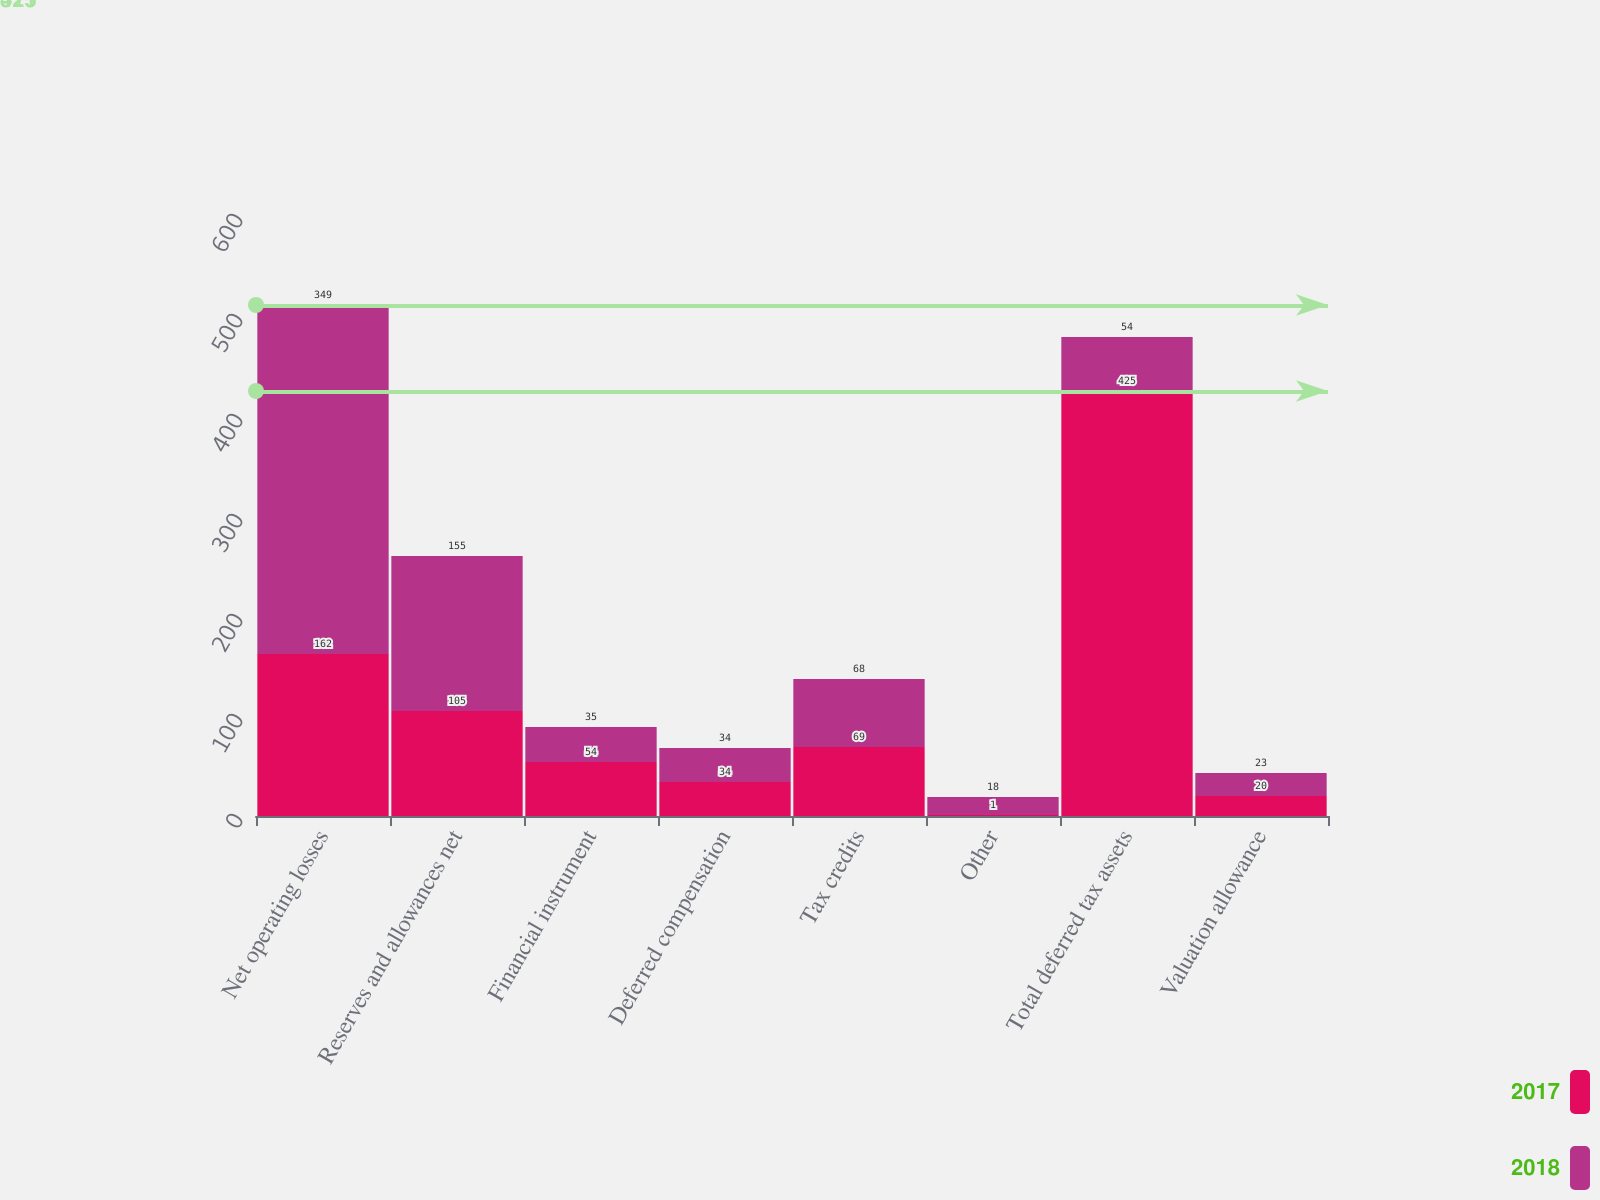Convert chart to OTSL. <chart><loc_0><loc_0><loc_500><loc_500><stacked_bar_chart><ecel><fcel>Net operating losses<fcel>Reserves and allowances net<fcel>Financial instrument<fcel>Deferred compensation<fcel>Tax credits<fcel>Other<fcel>Total deferred tax assets<fcel>Valuation allowance<nl><fcel>2017<fcel>162<fcel>105<fcel>54<fcel>34<fcel>69<fcel>1<fcel>425<fcel>20<nl><fcel>2018<fcel>349<fcel>155<fcel>35<fcel>34<fcel>68<fcel>18<fcel>54<fcel>23<nl></chart> 